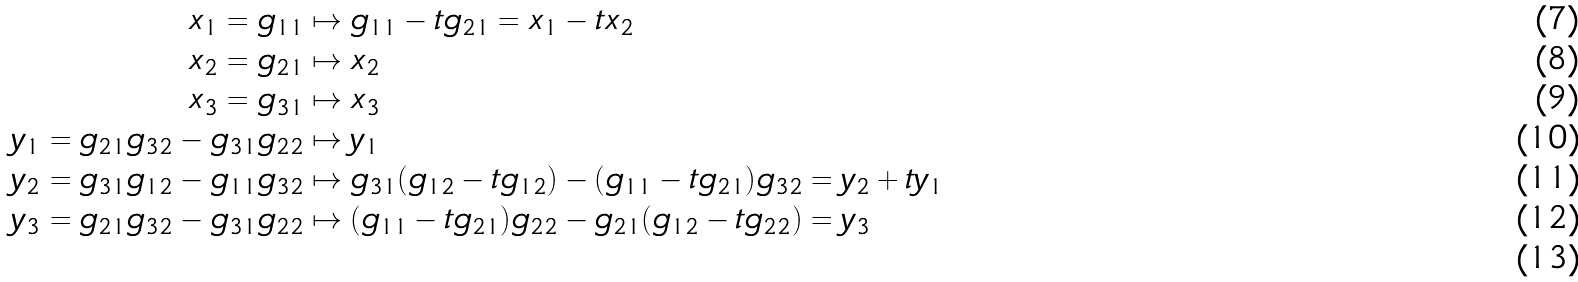<formula> <loc_0><loc_0><loc_500><loc_500>x _ { 1 } = g _ { 1 1 } & \mapsto g _ { 1 1 } - t g _ { 2 1 } = x _ { 1 } - t x _ { 2 } \\ x _ { 2 } = g _ { 2 1 } & \mapsto x _ { 2 } \\ x _ { 3 } = g _ { 3 1 } & \mapsto x _ { 3 } \\ y _ { 1 } = g _ { 2 1 } g _ { 3 2 } - g _ { 3 1 } g _ { 2 2 } & \mapsto y _ { 1 } \\ y _ { 2 } = g _ { 3 1 } g _ { 1 2 } - g _ { 1 1 } g _ { 3 2 } & \mapsto g _ { 3 1 } ( g _ { 1 2 } - t g _ { 1 2 } ) - ( g _ { 1 1 } - t g _ { 2 1 } ) g _ { 3 2 } = y _ { 2 } + t y _ { 1 } \\ y _ { 3 } = g _ { 2 1 } g _ { 3 2 } - g _ { 3 1 } g _ { 2 2 } & \mapsto ( g _ { 1 1 } - t g _ { 2 1 } ) g _ { 2 2 } - g _ { 2 1 } ( g _ { 1 2 } - t g _ { 2 2 } ) = y _ { 3 } \\</formula> 